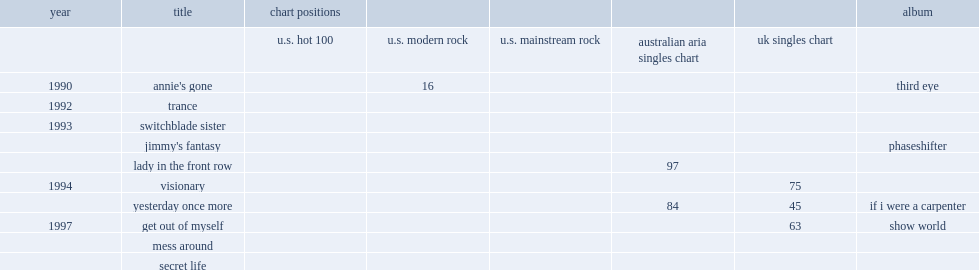In 1990, which album did redd kross release annie's gone from? Third eye. 